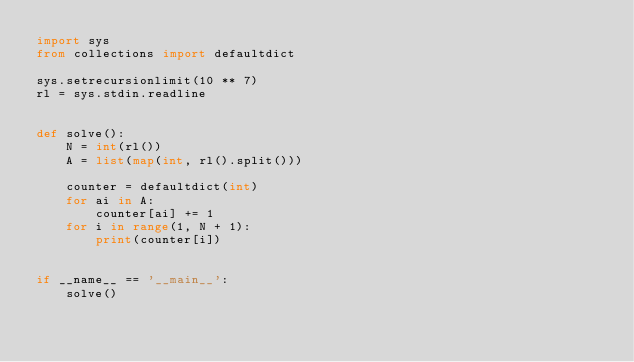Convert code to text. <code><loc_0><loc_0><loc_500><loc_500><_Python_>import sys
from collections import defaultdict

sys.setrecursionlimit(10 ** 7)
rl = sys.stdin.readline


def solve():
    N = int(rl())
    A = list(map(int, rl().split()))
    
    counter = defaultdict(int)
    for ai in A:
        counter[ai] += 1
    for i in range(1, N + 1):
        print(counter[i])


if __name__ == '__main__':
    solve()
</code> 